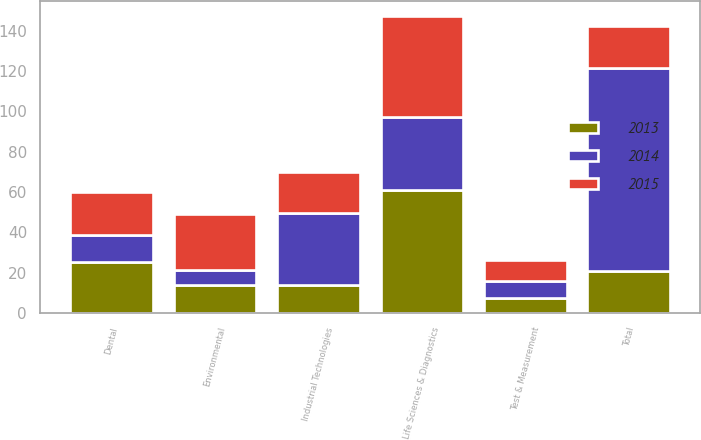Convert chart to OTSL. <chart><loc_0><loc_0><loc_500><loc_500><stacked_bar_chart><ecel><fcel>Test & Measurement<fcel>Environmental<fcel>Life Sciences & Diagnostics<fcel>Dental<fcel>Industrial Technologies<fcel>Total<nl><fcel>2013<fcel>7.4<fcel>13.9<fcel>61.2<fcel>25.3<fcel>14<fcel>20.8<nl><fcel>2015<fcel>10.7<fcel>27.9<fcel>50.2<fcel>21.4<fcel>20.2<fcel>20.8<nl><fcel>2014<fcel>8.3<fcel>7.4<fcel>36.1<fcel>13.3<fcel>35.6<fcel>100.7<nl></chart> 